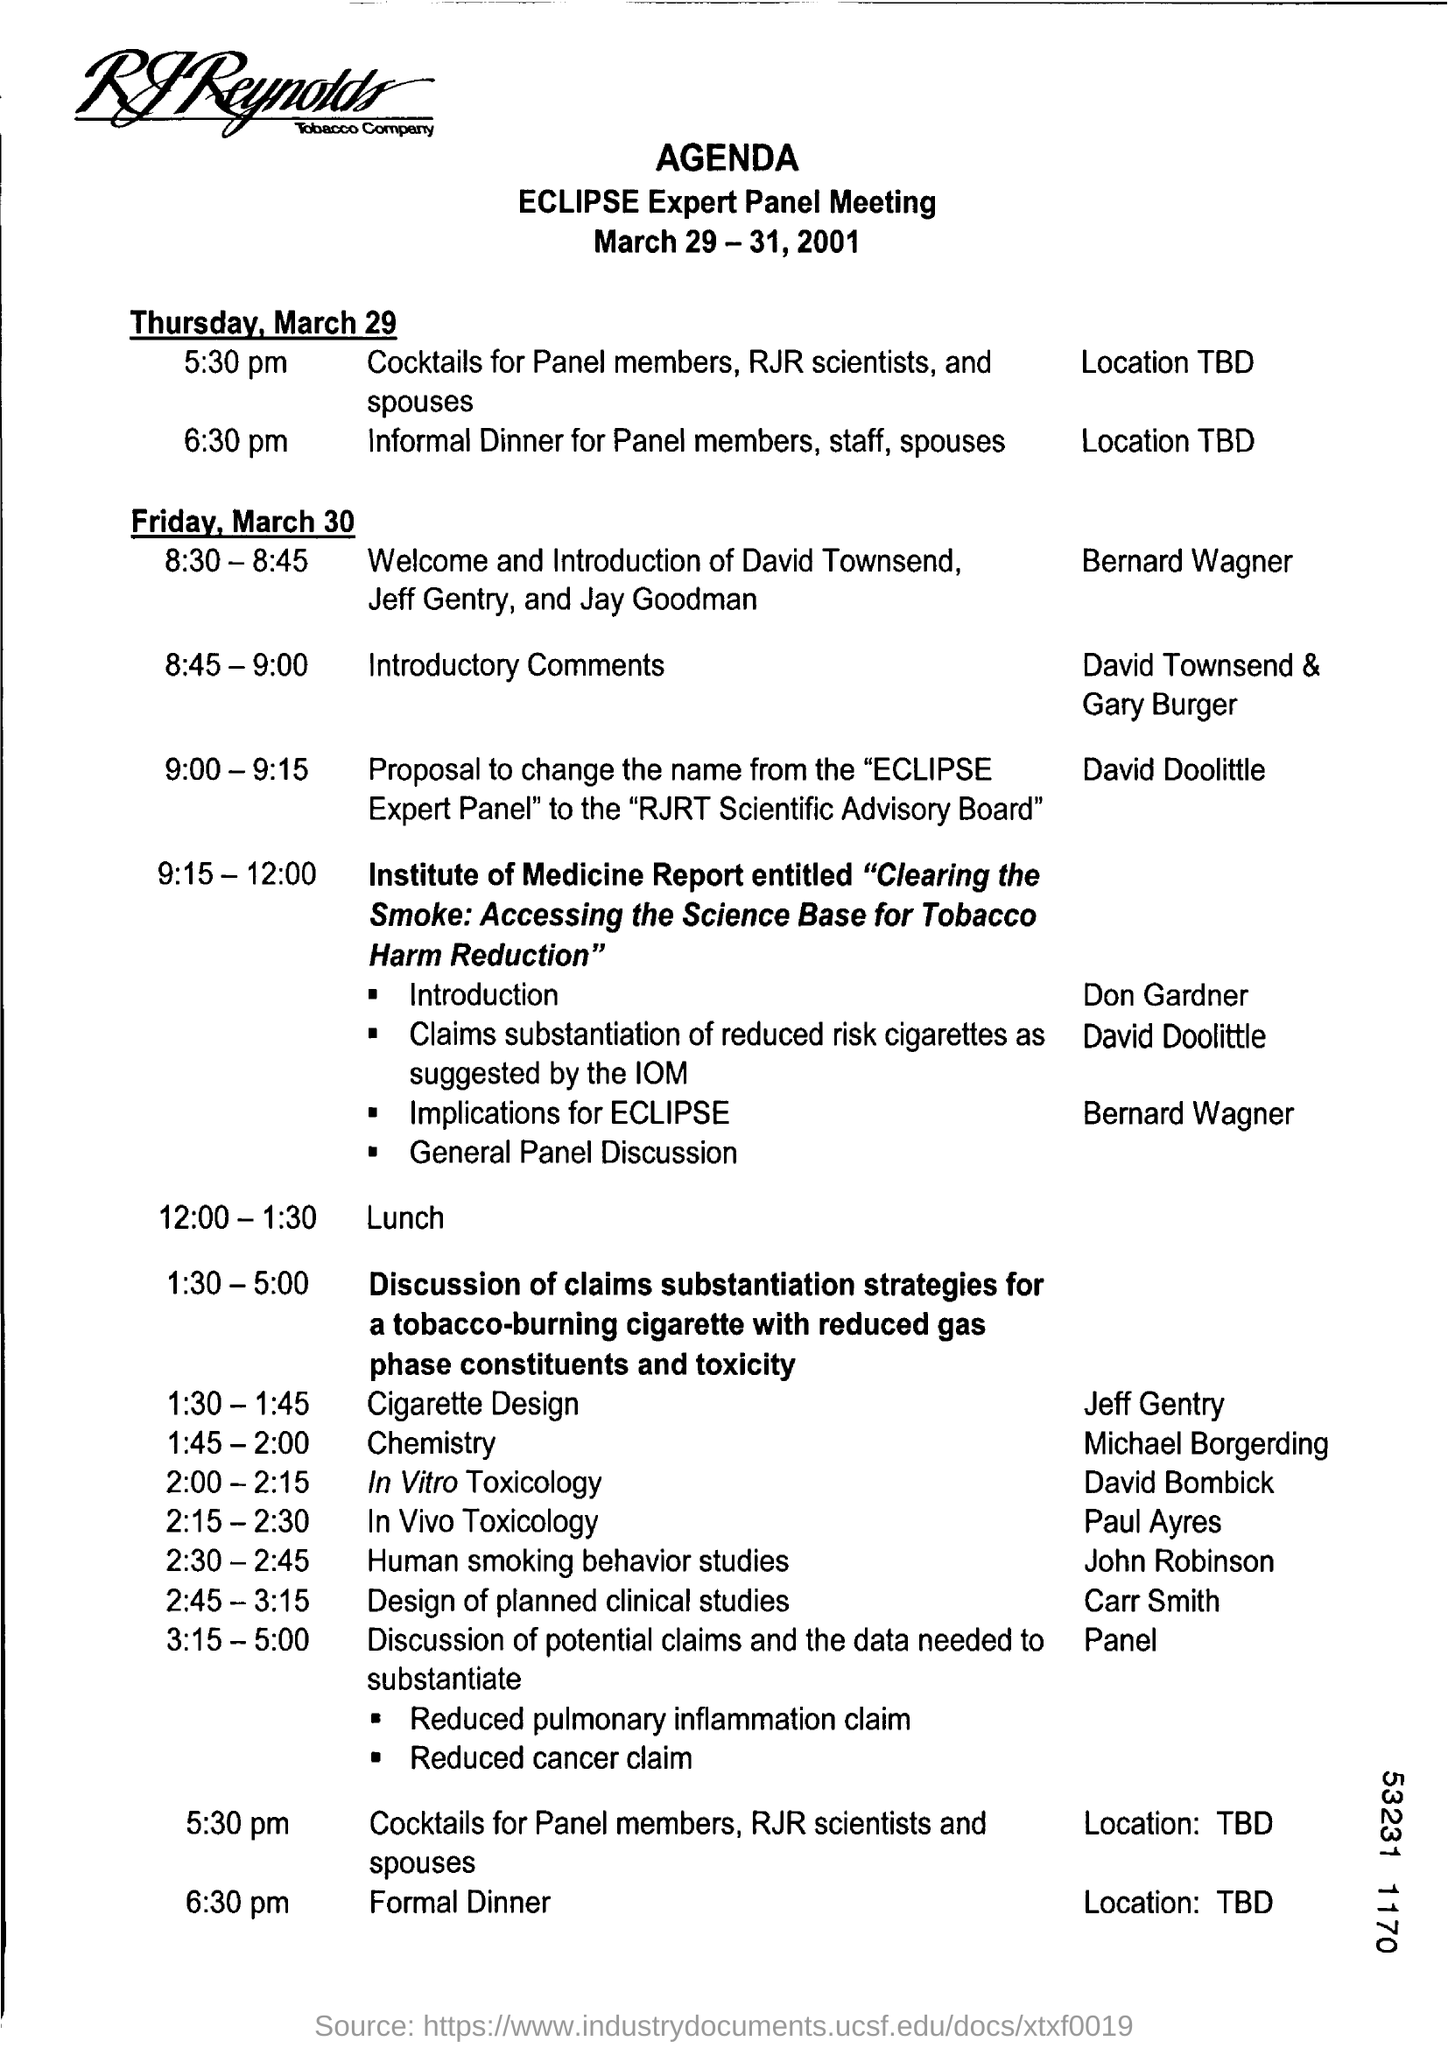Highlight a few significant elements in this photo. The agenda for the meeting is for the Eclipse Expert Panel meeting. The meeting will be held on March 29-31, 2001. The lunch is scheduled to take place from 12:00 PM to 1:30 PM. It is expected that David Townsend and Gary Burger will be providing the introductory comments for the upcoming event. The first agenda for Friday, March 30th will consist of a welcome and introduction of David Townsend, Jeff Gentry, and Jay Goodman. 